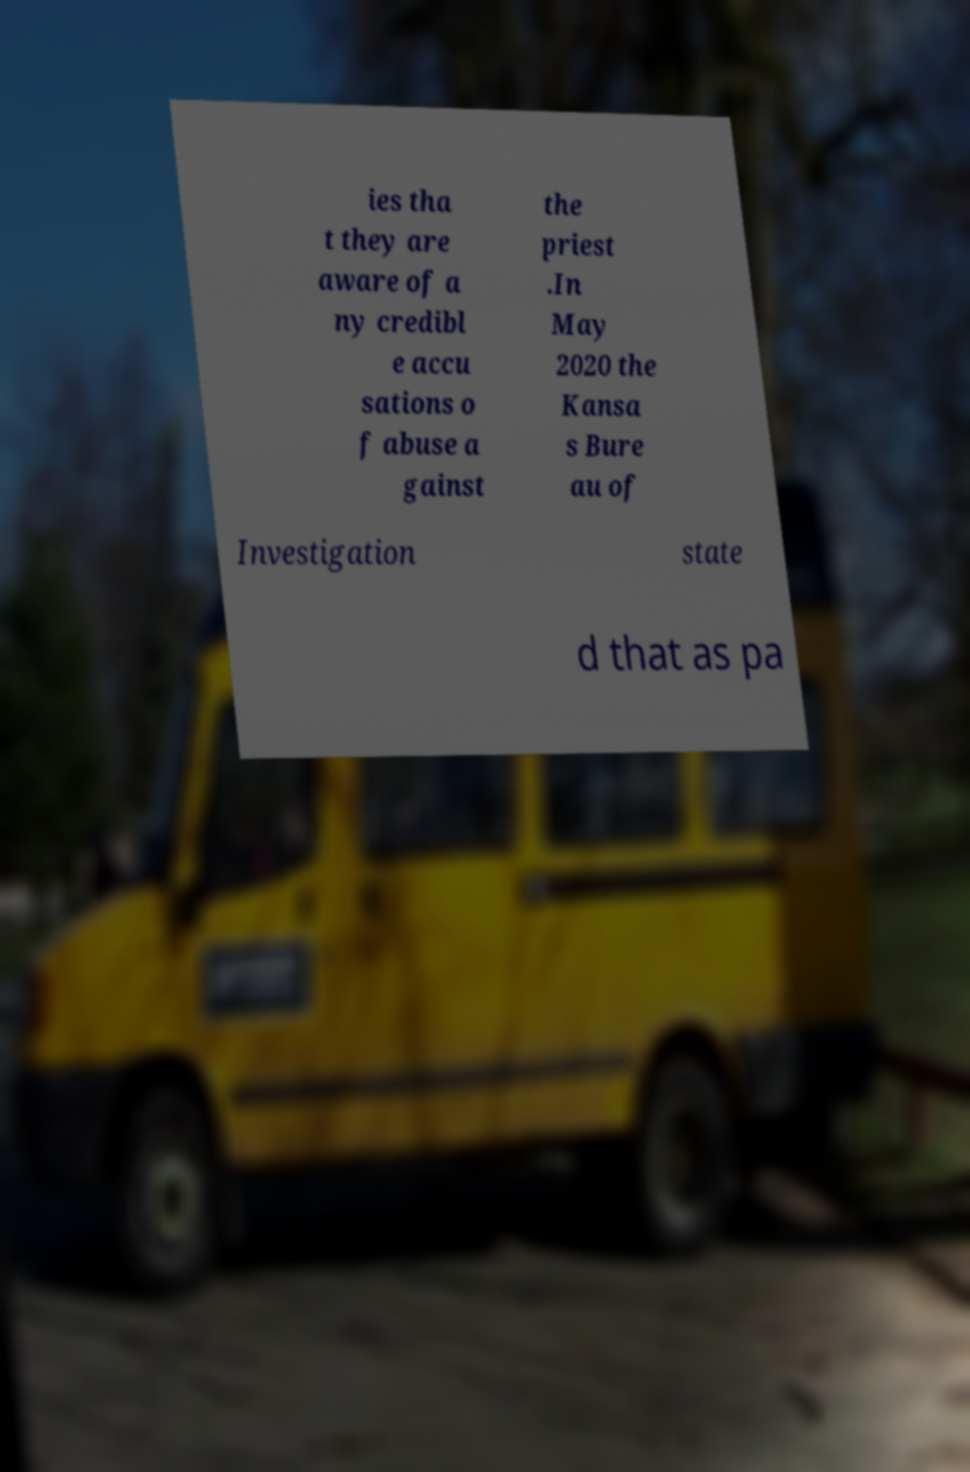Could you extract and type out the text from this image? ies tha t they are aware of a ny credibl e accu sations o f abuse a gainst the priest .In May 2020 the Kansa s Bure au of Investigation state d that as pa 